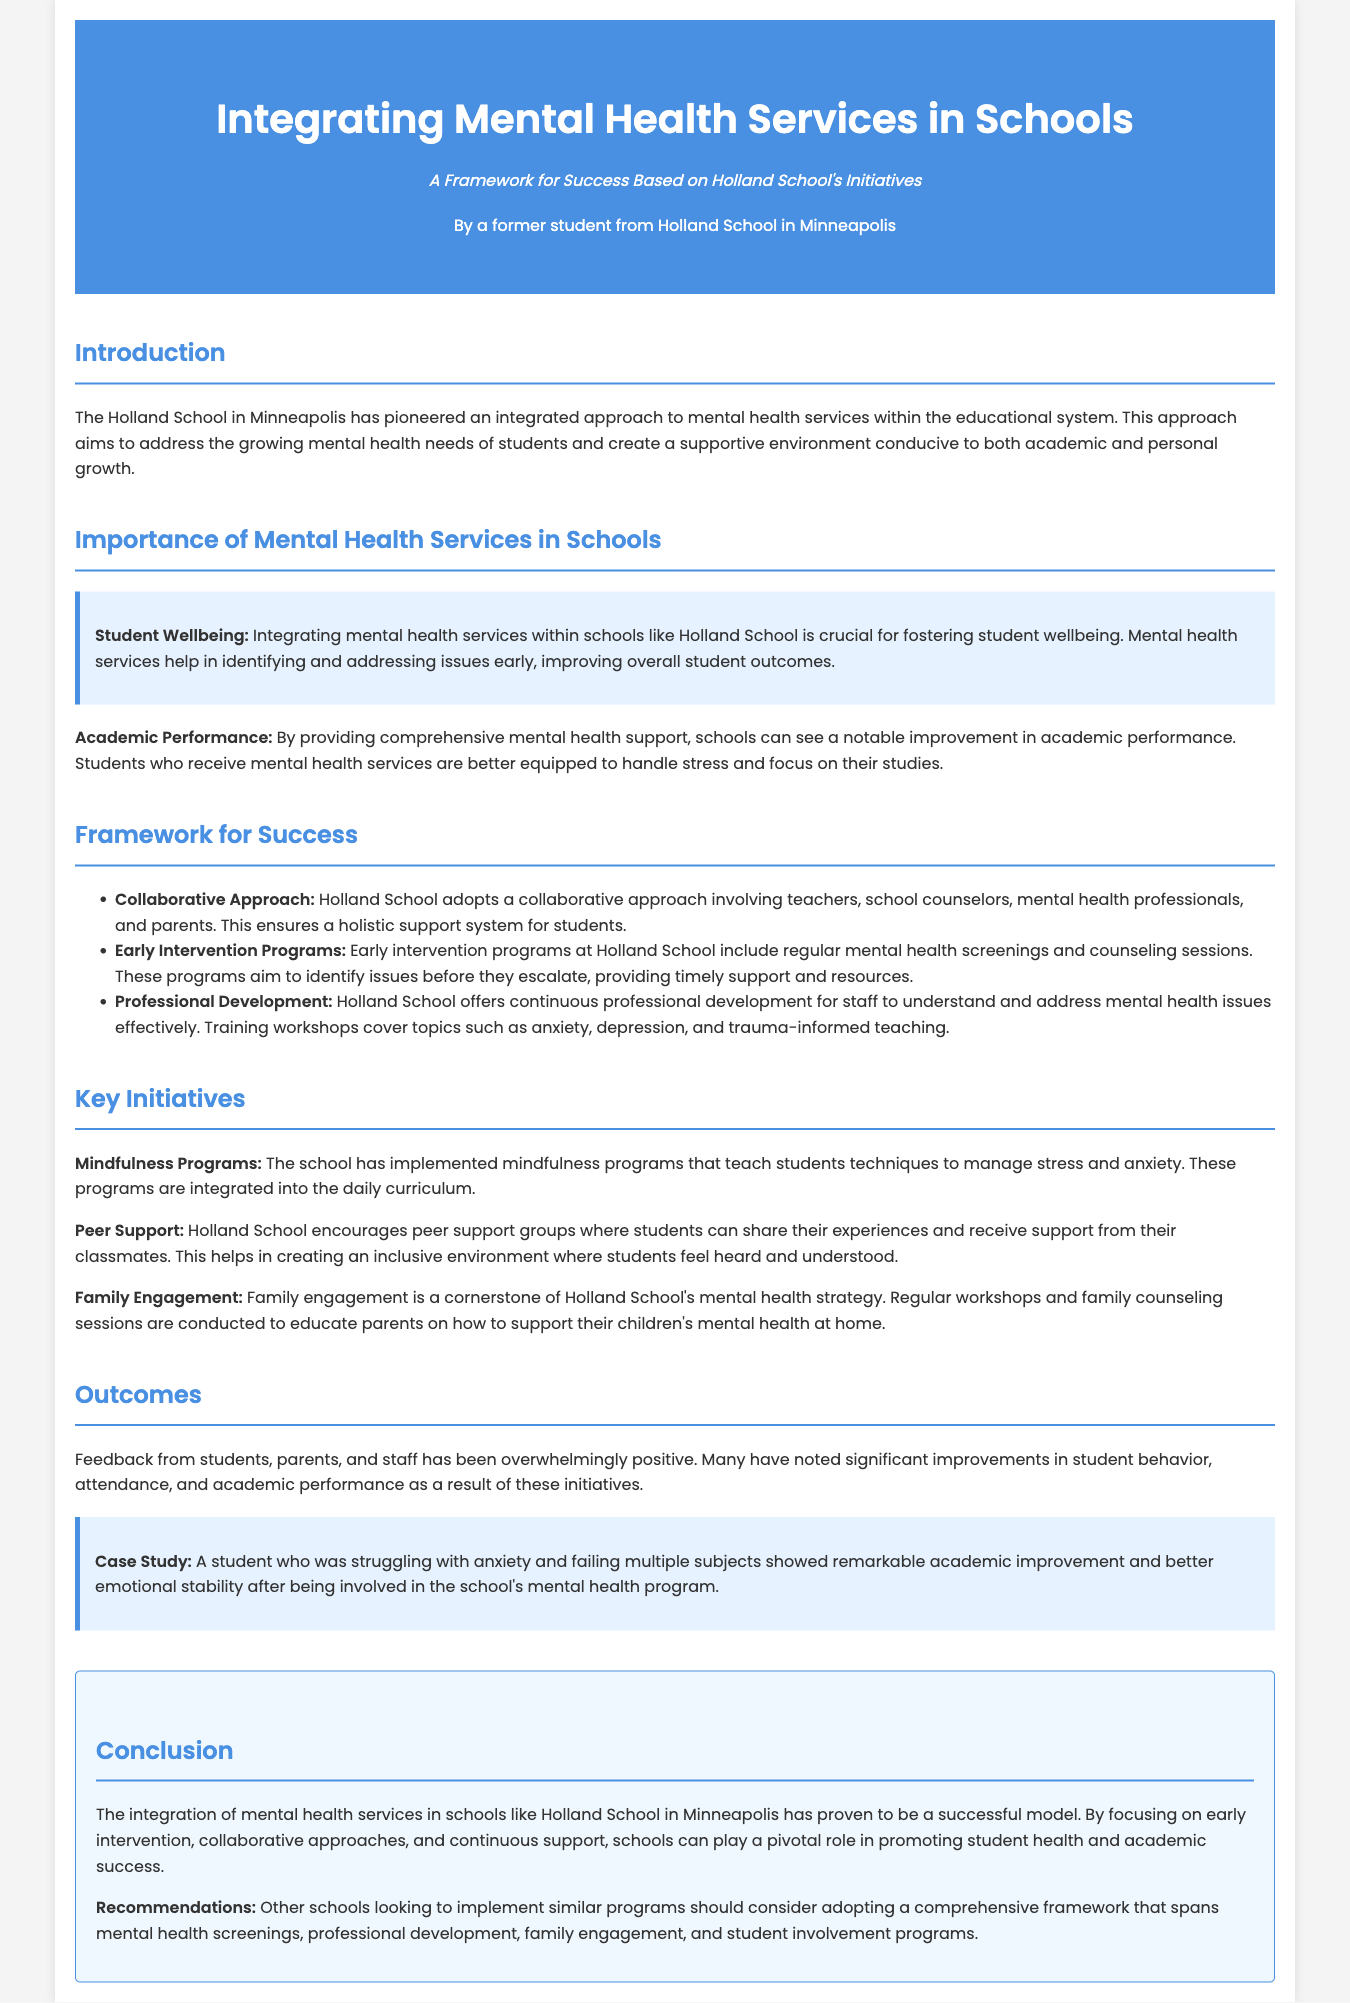what is the title of the document? The title of the document is stated in the header section.
Answer: Integrating Mental Health Services in Schools who is the author of the document? The author is mentioned just below the title in the header section.
Answer: A former student from Holland School in Minneapolis what initiative is focused on stress management? This initiative is mentioned in the Key Initiatives section.
Answer: Mindfulness Programs which approach does Holland School adopt for mental health services? This is stated in the Framework for Success section.
Answer: Collaborative Approach what is a key outcome noted in the document? This is stated in the Outcomes section, referencing feedback from the community.
Answer: Improvement in student behavior how are parents involved in Holland School's mental health strategy? This is explained in the Key Initiatives section.
Answer: Family Engagement what is a recommendation for other schools? This is included in the conclusion section as part of recommendations.
Answer: Comprehensive framework how does the document describe the impact of mental health services on academic performance? The document discusses this in the Importance of Mental Health Services section.
Answer: Notable improvement what key programs help identify issues early? This is noted in the Framework for Success section.
Answer: Early Intervention Programs 